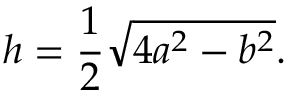<formula> <loc_0><loc_0><loc_500><loc_500>h = { \frac { 1 } { 2 } } { \sqrt { 4 a ^ { 2 } - b ^ { 2 } } } .</formula> 